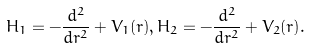<formula> <loc_0><loc_0><loc_500><loc_500>H _ { 1 } = - \frac { d ^ { 2 } } { d r ^ { 2 } } + V _ { 1 } ( r ) , H _ { 2 } = - \frac { d ^ { 2 } } { d r ^ { 2 } } + V _ { 2 } ( r ) .</formula> 